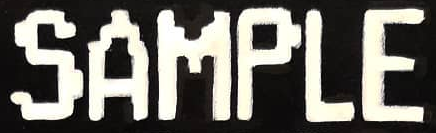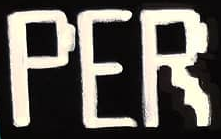What text appears in these images from left to right, separated by a semicolon? SAMPLE; PER 